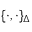Convert formula to latex. <formula><loc_0><loc_0><loc_500><loc_500>{ \{ \cdot , \cdot \} _ { \Delta } }</formula> 